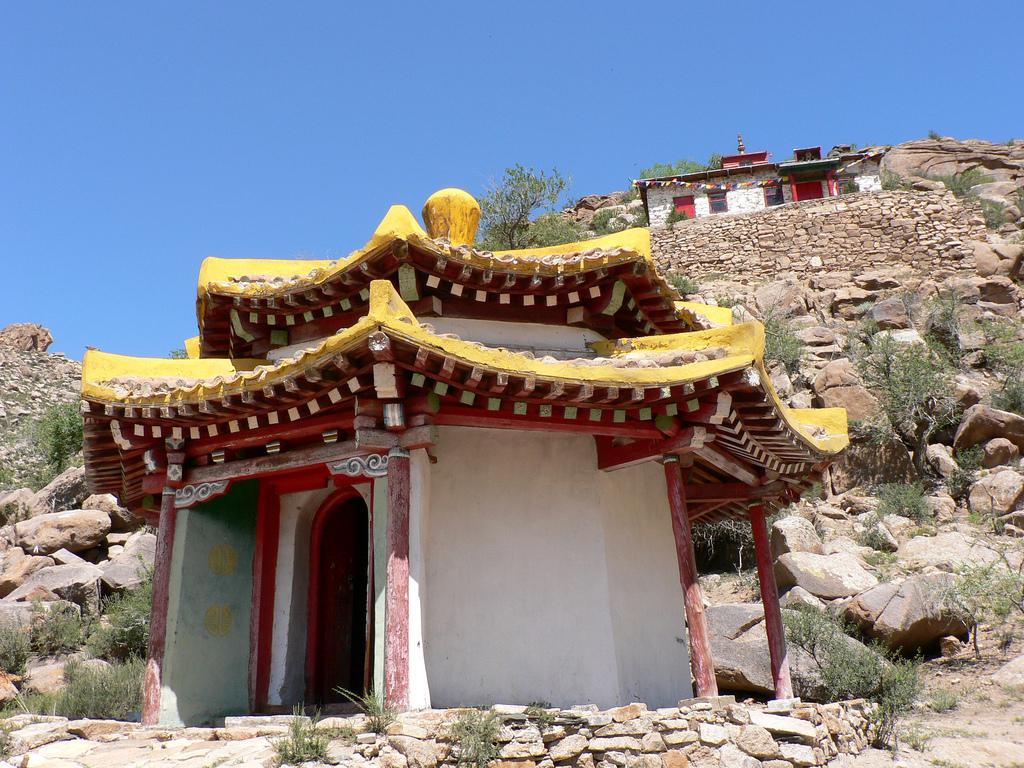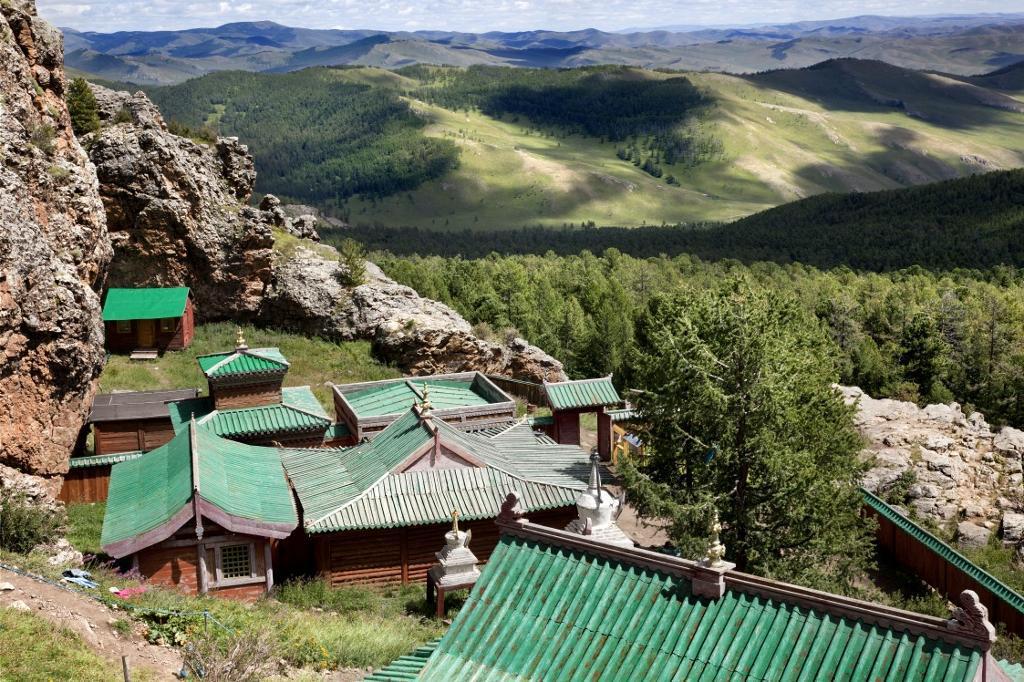The first image is the image on the left, the second image is the image on the right. Given the left and right images, does the statement "One of the buildings has gold trimming on the roof." hold true? Answer yes or no. Yes. The first image is the image on the left, the second image is the image on the right. Examine the images to the left and right. Is the description "An image shows a structure with a yellow trimmed roof and a bulb-like yellow topper." accurate? Answer yes or no. Yes. 